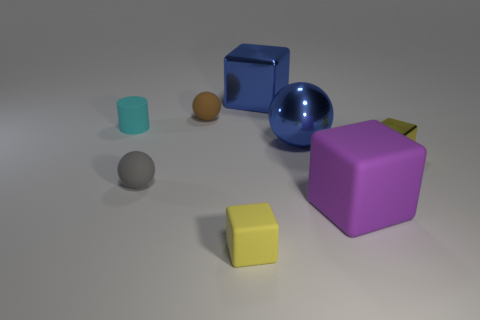Add 1 small cyan objects. How many objects exist? 9 Subtract all yellow balls. Subtract all yellow cylinders. How many balls are left? 3 Subtract all balls. How many objects are left? 5 Subtract 0 yellow spheres. How many objects are left? 8 Subtract all small blue objects. Subtract all tiny blocks. How many objects are left? 6 Add 8 small blocks. How many small blocks are left? 10 Add 4 small yellow metallic blocks. How many small yellow metallic blocks exist? 5 